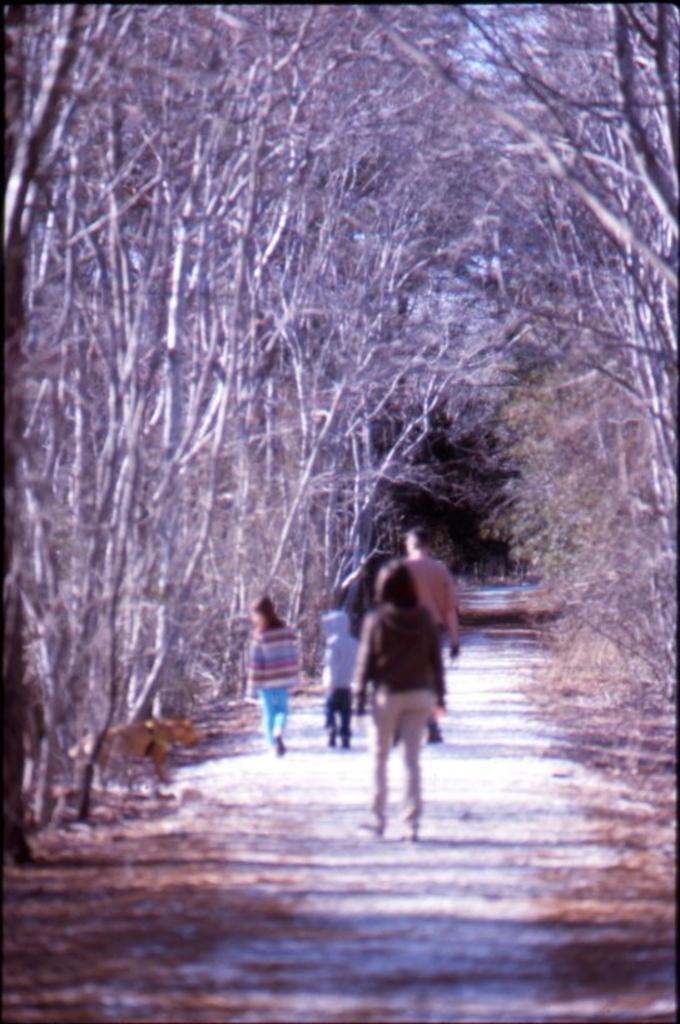Could you give a brief overview of what you see in this image? In this image we can see a group of people standing on the pathway. We can also see a group of trees. 